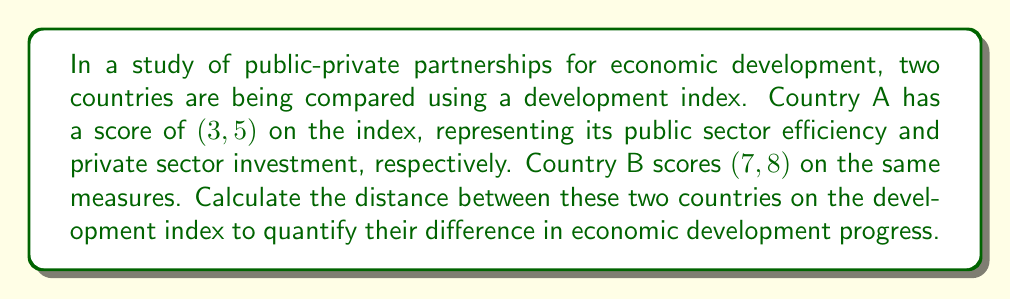Could you help me with this problem? To solve this problem, we'll use the distance formula derived from the Pythagorean theorem:

1) The distance formula between two points $(x_1, y_1)$ and $(x_2, y_2)$ is:

   $$d = \sqrt{(x_2 - x_1)^2 + (y_2 - y_1)^2}$$

2) In this case:
   $(x_1, y_1) = (3, 5)$ for Country A
   $(x_2, y_2) = (7, 8)$ for Country B

3) Let's substitute these values into the formula:

   $$d = \sqrt{(7 - 3)^2 + (8 - 5)^2}$$

4) Simplify the expressions inside the parentheses:

   $$d = \sqrt{4^2 + 3^2}$$

5) Calculate the squares:

   $$d = \sqrt{16 + 9}$$

6) Add under the square root:

   $$d = \sqrt{25}$$

7) Simplify the square root:

   $$d = 5$$

Therefore, the distance between the two countries on the development index is 5 units.
Answer: $5$ units 